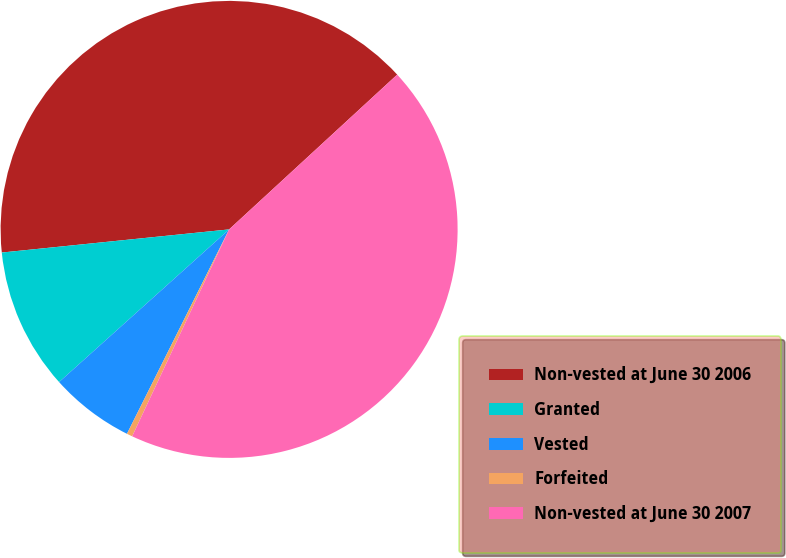<chart> <loc_0><loc_0><loc_500><loc_500><pie_chart><fcel>Non-vested at June 30 2006<fcel>Granted<fcel>Vested<fcel>Forfeited<fcel>Non-vested at June 30 2007<nl><fcel>39.77%<fcel>10.03%<fcel>5.98%<fcel>0.4%<fcel>43.82%<nl></chart> 